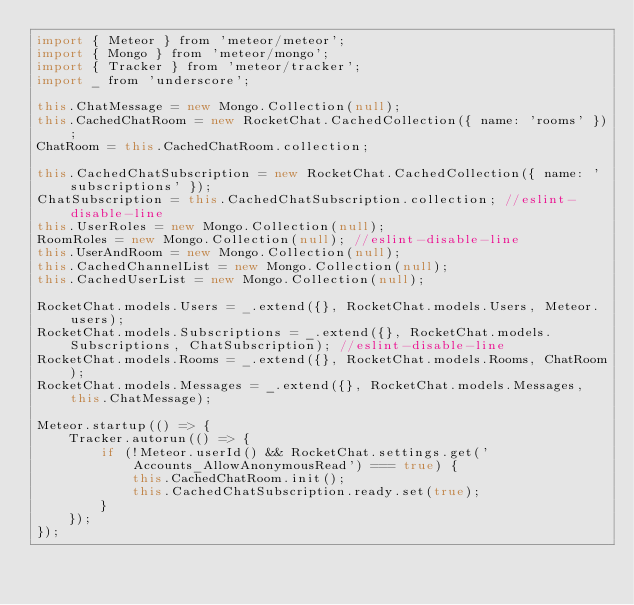Convert code to text. <code><loc_0><loc_0><loc_500><loc_500><_JavaScript_>import { Meteor } from 'meteor/meteor';
import { Mongo } from 'meteor/mongo';
import { Tracker } from 'meteor/tracker';
import _ from 'underscore';

this.ChatMessage = new Mongo.Collection(null);
this.CachedChatRoom = new RocketChat.CachedCollection({ name: 'rooms' });
ChatRoom = this.CachedChatRoom.collection;

this.CachedChatSubscription = new RocketChat.CachedCollection({ name: 'subscriptions' });
ChatSubscription = this.CachedChatSubscription.collection; //eslint-disable-line
this.UserRoles = new Mongo.Collection(null);
RoomRoles = new Mongo.Collection(null); //eslint-disable-line
this.UserAndRoom = new Mongo.Collection(null);
this.CachedChannelList = new Mongo.Collection(null);
this.CachedUserList = new Mongo.Collection(null);

RocketChat.models.Users = _.extend({}, RocketChat.models.Users, Meteor.users);
RocketChat.models.Subscriptions = _.extend({}, RocketChat.models.Subscriptions, ChatSubscription); //eslint-disable-line
RocketChat.models.Rooms = _.extend({}, RocketChat.models.Rooms, ChatRoom);
RocketChat.models.Messages = _.extend({}, RocketChat.models.Messages, this.ChatMessage);

Meteor.startup(() => {
	Tracker.autorun(() => {
		if (!Meteor.userId() && RocketChat.settings.get('Accounts_AllowAnonymousRead') === true) {
			this.CachedChatRoom.init();
			this.CachedChatSubscription.ready.set(true);
		}
	});
});
</code> 